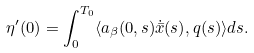<formula> <loc_0><loc_0><loc_500><loc_500>\eta ^ { \prime } ( 0 ) = \int _ { 0 } ^ { T _ { 0 } } \langle a _ { \beta } ( 0 , s ) \dot { \bar { x } } ( s ) , q ( s ) \rangle d s .</formula> 